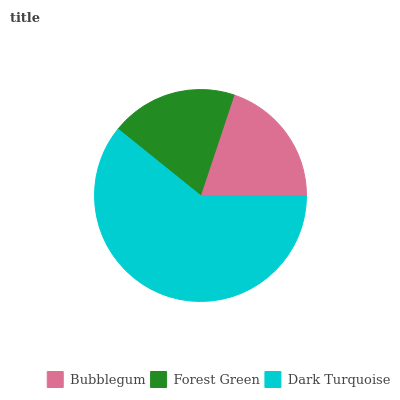Is Forest Green the minimum?
Answer yes or no. Yes. Is Dark Turquoise the maximum?
Answer yes or no. Yes. Is Dark Turquoise the minimum?
Answer yes or no. No. Is Forest Green the maximum?
Answer yes or no. No. Is Dark Turquoise greater than Forest Green?
Answer yes or no. Yes. Is Forest Green less than Dark Turquoise?
Answer yes or no. Yes. Is Forest Green greater than Dark Turquoise?
Answer yes or no. No. Is Dark Turquoise less than Forest Green?
Answer yes or no. No. Is Bubblegum the high median?
Answer yes or no. Yes. Is Bubblegum the low median?
Answer yes or no. Yes. Is Dark Turquoise the high median?
Answer yes or no. No. Is Forest Green the low median?
Answer yes or no. No. 